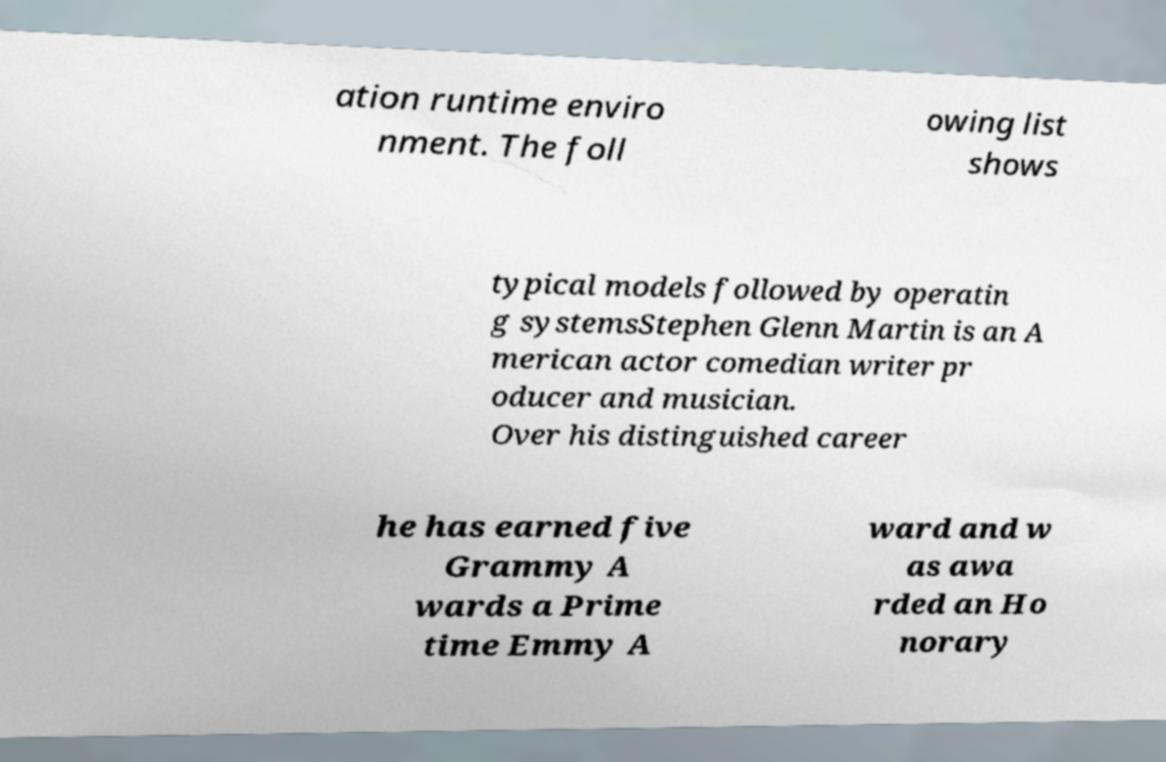Could you assist in decoding the text presented in this image and type it out clearly? ation runtime enviro nment. The foll owing list shows typical models followed by operatin g systemsStephen Glenn Martin is an A merican actor comedian writer pr oducer and musician. Over his distinguished career he has earned five Grammy A wards a Prime time Emmy A ward and w as awa rded an Ho norary 